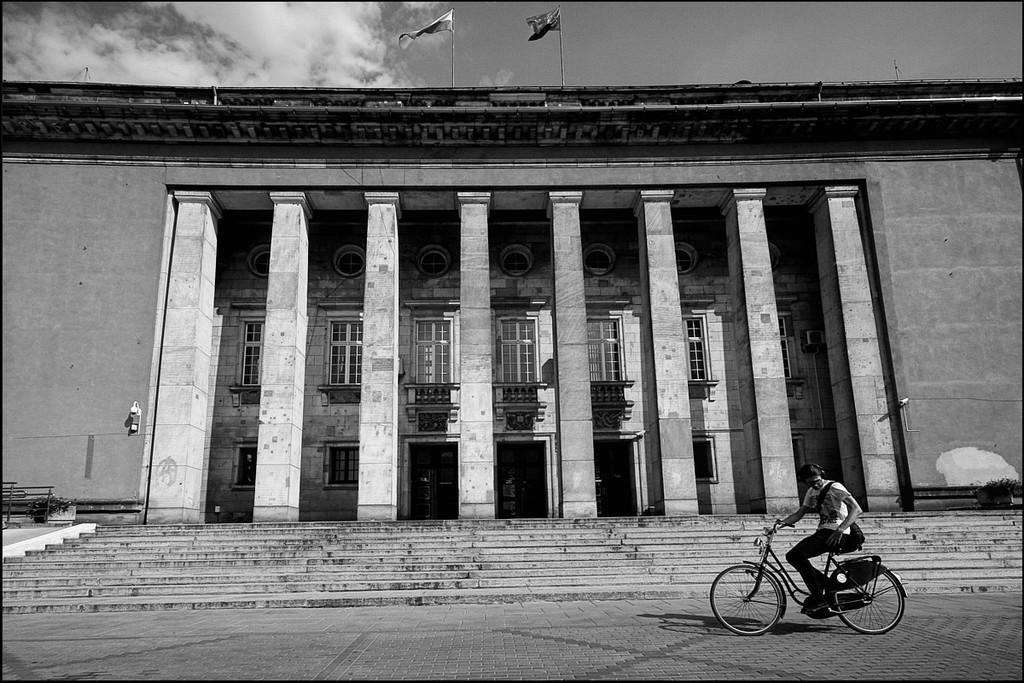How would you summarize this image in a sentence or two? This picture is clicked outside a building. There is a big building in the image. To it there are pillars, windows, railing, doors and ventilators. In front of it there is a staircase. On the building there are flags. To the right corner and left corner there are flower pots. In front of the building there is a person riding bicycle. To the top there is sky with clouds. 